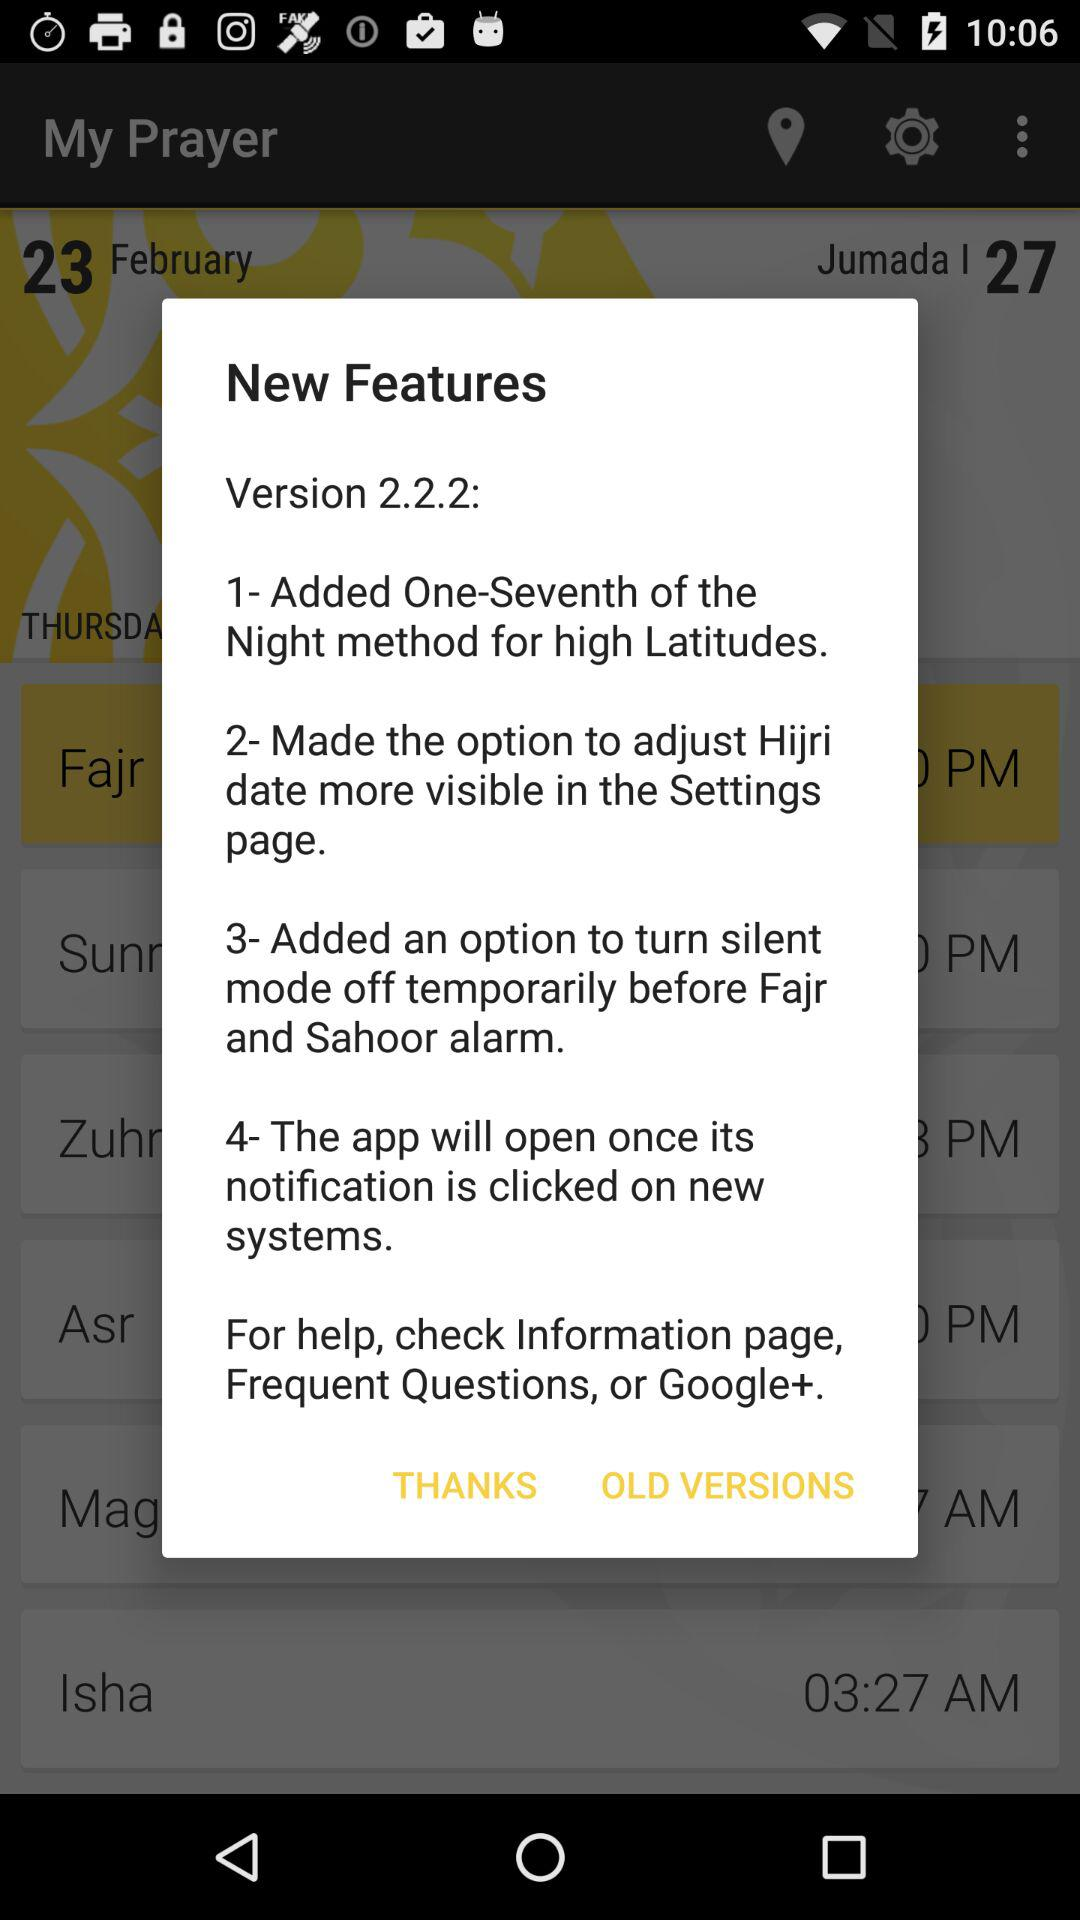Which prayer is at 4:44 AM?
When the provided information is insufficient, respond with <no answer>. <no answer> 